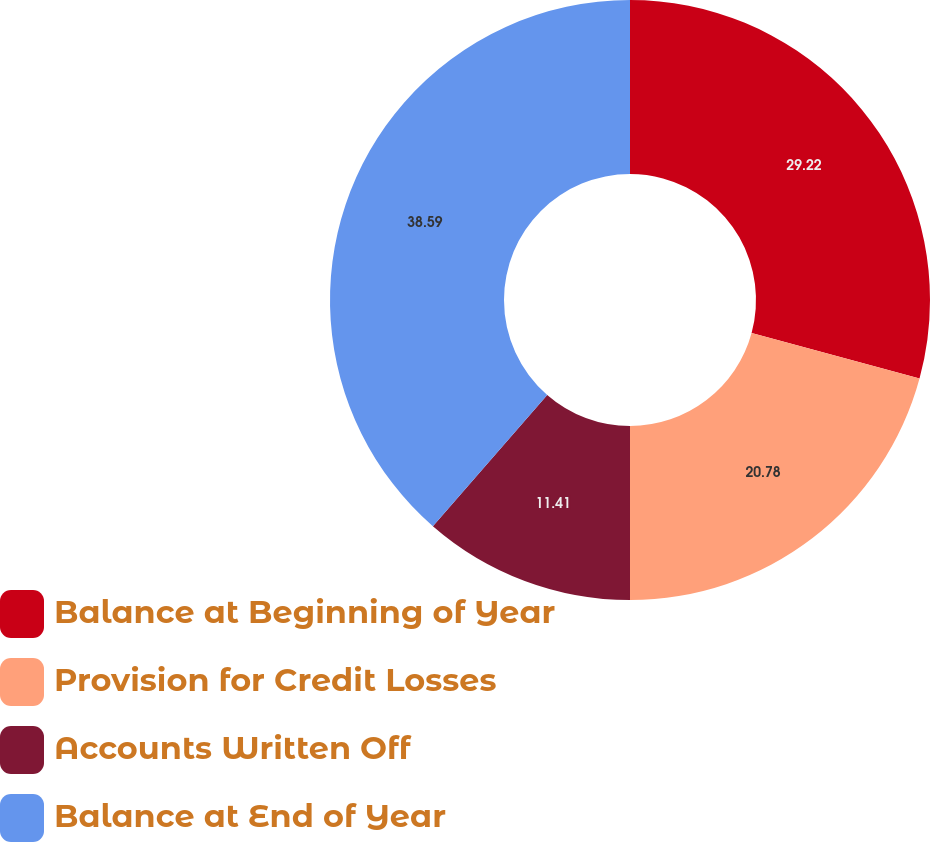Convert chart to OTSL. <chart><loc_0><loc_0><loc_500><loc_500><pie_chart><fcel>Balance at Beginning of Year<fcel>Provision for Credit Losses<fcel>Accounts Written Off<fcel>Balance at End of Year<nl><fcel>29.22%<fcel>20.78%<fcel>11.41%<fcel>38.59%<nl></chart> 